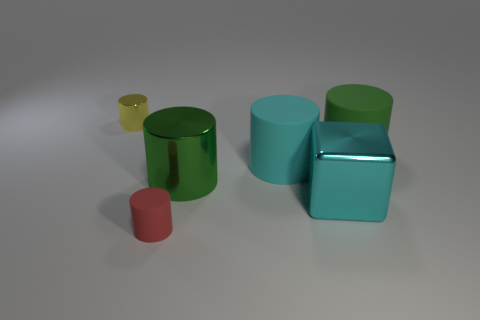Subtract all large cyan cylinders. How many cylinders are left? 4 Subtract all yellow cylinders. How many cylinders are left? 4 Subtract all blue cylinders. Subtract all gray balls. How many cylinders are left? 5 Add 3 tiny rubber objects. How many objects exist? 9 Subtract all cubes. How many objects are left? 5 Subtract all yellow matte cylinders. Subtract all tiny red cylinders. How many objects are left? 5 Add 4 green cylinders. How many green cylinders are left? 6 Add 6 small things. How many small things exist? 8 Subtract 0 gray cylinders. How many objects are left? 6 